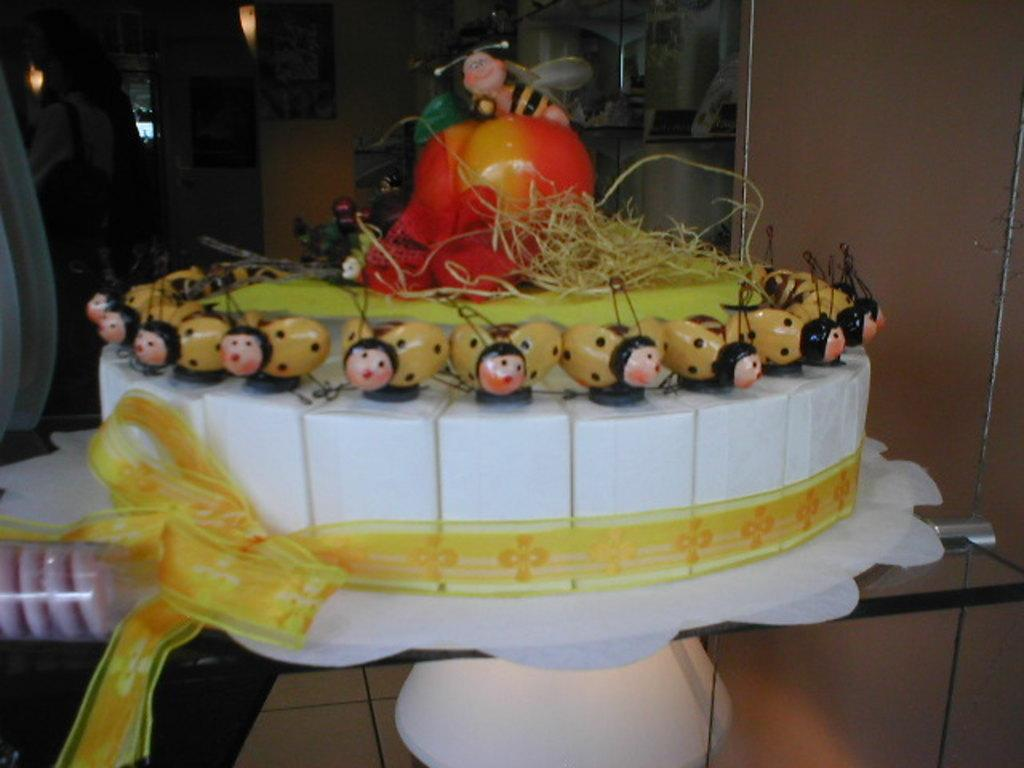What is on the table in the image? There is a cake on the table in the image. What can be seen in the background of the image? There are objects visible in the background of the image. Where is the person located in the image? The person is on the left side of the image. What type of seed is the person planting in the image? There is no seed or planting activity present in the image. Can you describe the snake that is slithering across the table in the image? There is no snake present in the image; the main subject on the table is a cake. 